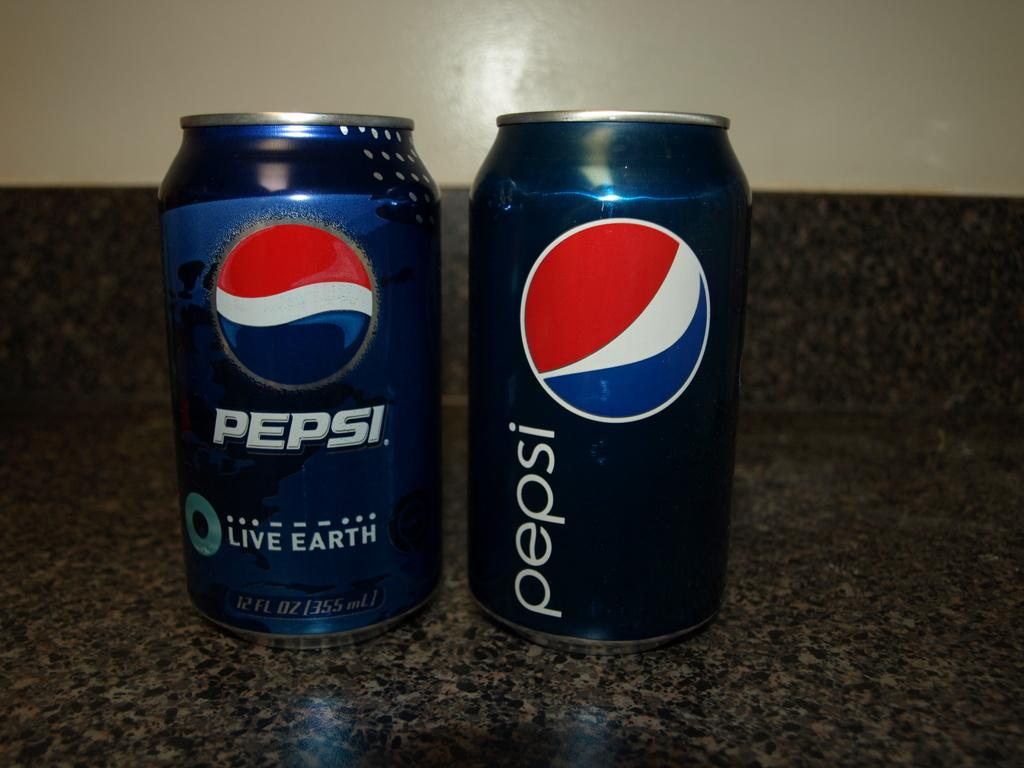<image>
Create a compact narrative representing the image presented. Two Pepsi cans on top of a counter with one saying "Live Earth". 